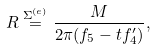Convert formula to latex. <formula><loc_0><loc_0><loc_500><loc_500>R \stackrel { \Sigma ^ { ( e ) } } { = } \frac { M } { 2 \pi ( f _ { 5 } - t f _ { 4 } ^ { \prime } ) } ,</formula> 